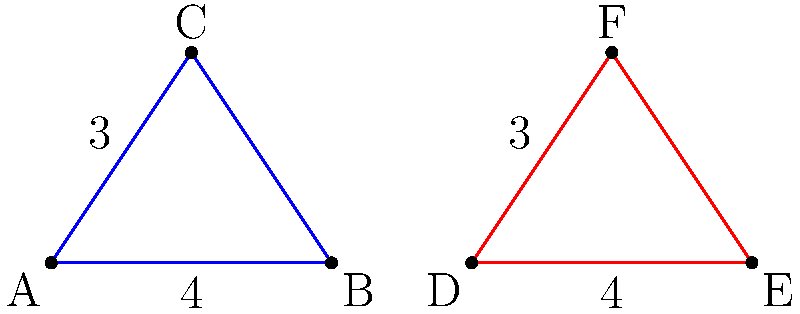In your latest analysis of Martian crater patterns, you've identified two triangular formations that appear strikingly similar. Triangle ABC represents a crater formation in the Acidalia Planitia region, while triangle DEF represents a formation in the Utopia Planitia region. Given that AB = 4 units, AC = 3 units, DE = 4 units, and DF = 3 units, what additional information would you need to prove that these triangular crater formations are congruent, potentially indicating a common extraterrestrial origin? To prove that two triangles are congruent, we need to use one of the congruence criteria. Let's approach this step-by-step:

1. We already know that:
   AB = DE = 4 units
   AC = DF = 3 units

2. This gives us two pairs of equal sides (Side-Side or SS), but this is not sufficient to prove congruence.

3. The congruence criteria we can use are:
   - SSS (Side-Side-Side): All three pairs of corresponding sides are equal
   - SAS (Side-Angle-Side): Two pairs of sides and the included angle are equal
   - ASA (Angle-Side-Angle): Two pairs of angles and the included side are equal
   - AAS (Angle-Angle-Side): Two pairs of angles and a non-included side are equal

4. Given the information we have (SS), the most straightforward way to prove congruence would be to use the SSS criterion.

5. Therefore, we need to know the length of the third side in each triangle: BC and EF.

6. If BC = EF, then we would have SSS, and the triangles would be proven congruent.

7. Alternatively, if we knew that angle BAC = angle EDF, we could use the SAS criterion to prove congruence.

Therefore, to prove that these triangular crater formations are congruent, we need either the length of BC (or EF), or the measure of angle BAC (or EDF).
Answer: Length of BC (or EF) 